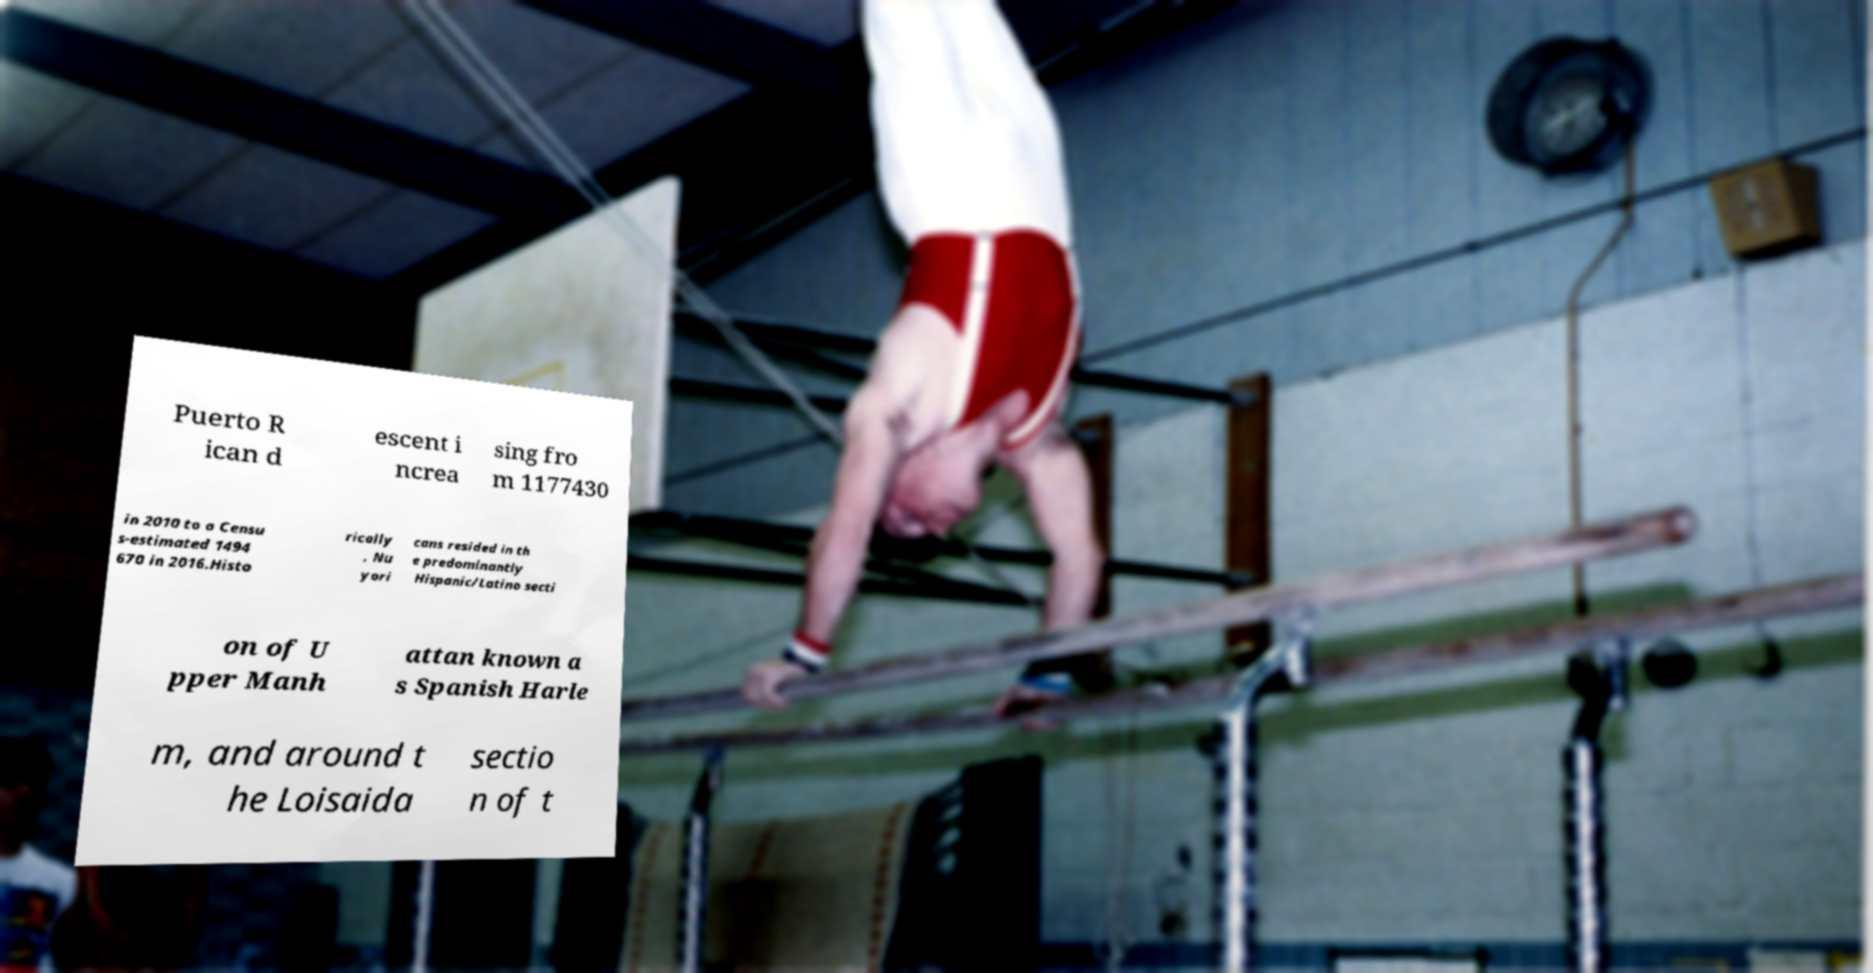What messages or text are displayed in this image? I need them in a readable, typed format. Puerto R ican d escent i ncrea sing fro m 1177430 in 2010 to a Censu s-estimated 1494 670 in 2016.Histo rically , Nu yori cans resided in th e predominantly Hispanic/Latino secti on of U pper Manh attan known a s Spanish Harle m, and around t he Loisaida sectio n of t 